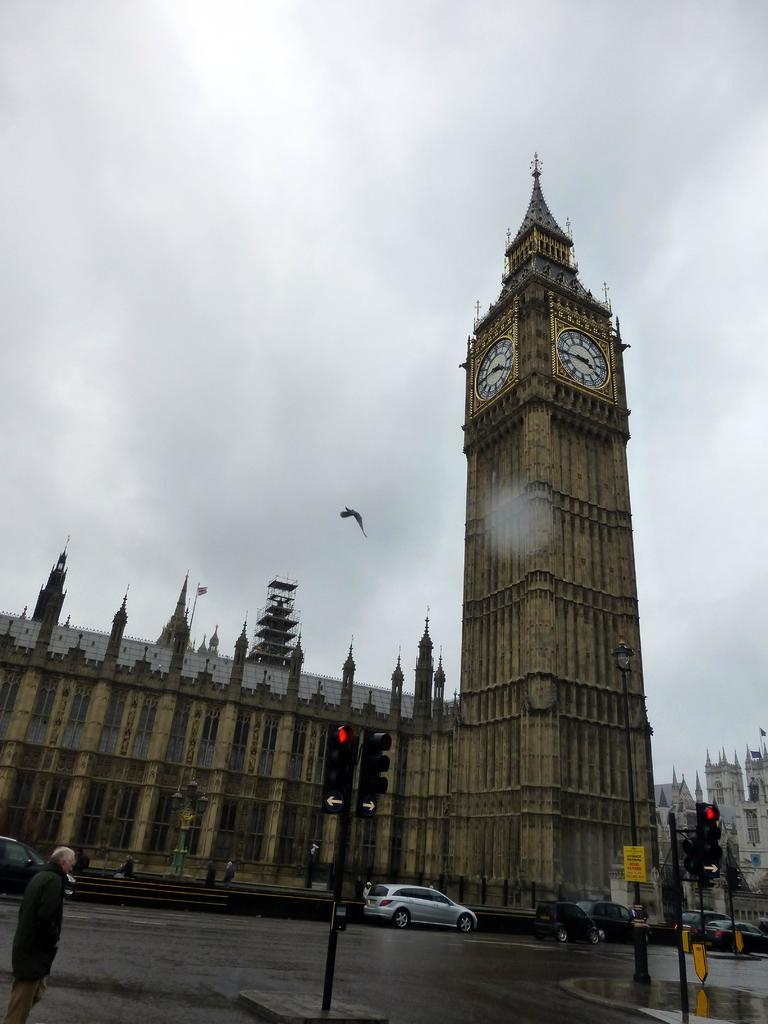What types of objects are on the ground in the image? There are vehicles on the ground in the image. Can you describe the people visible in the image? There are people visible in the image. What type of traffic control devices are present in the image? Traffic signals are present in the image. What type of vertical structures can be seen in the image? Poles are visible in the image. What type of signage is present in the image? A name board is present in the image. What type of structures are visible in the image? Buildings are visible in the image. Are there any unspecified objects in the image? Yes, there are some unspecified objects in the image. What can be seen in the background of the image? The sky is visible in the background of the image. How many babies are playing with the faucet in the image? There are no babies or faucets present in the image. What type of pleasure can be seen being experienced by the people in the image? There is no indication of pleasure being experienced by the people in the image. 